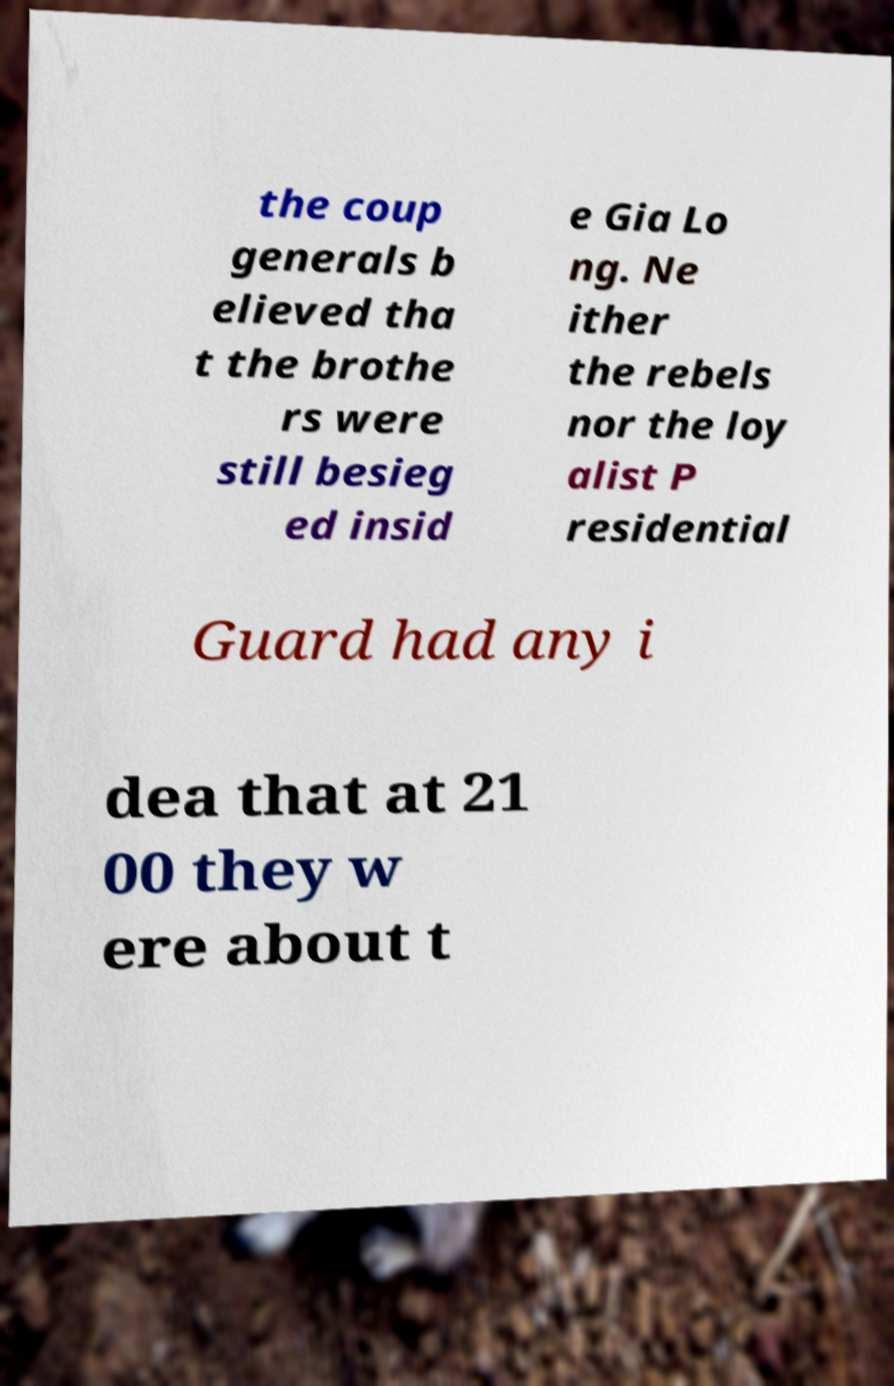There's text embedded in this image that I need extracted. Can you transcribe it verbatim? the coup generals b elieved tha t the brothe rs were still besieg ed insid e Gia Lo ng. Ne ither the rebels nor the loy alist P residential Guard had any i dea that at 21 00 they w ere about t 